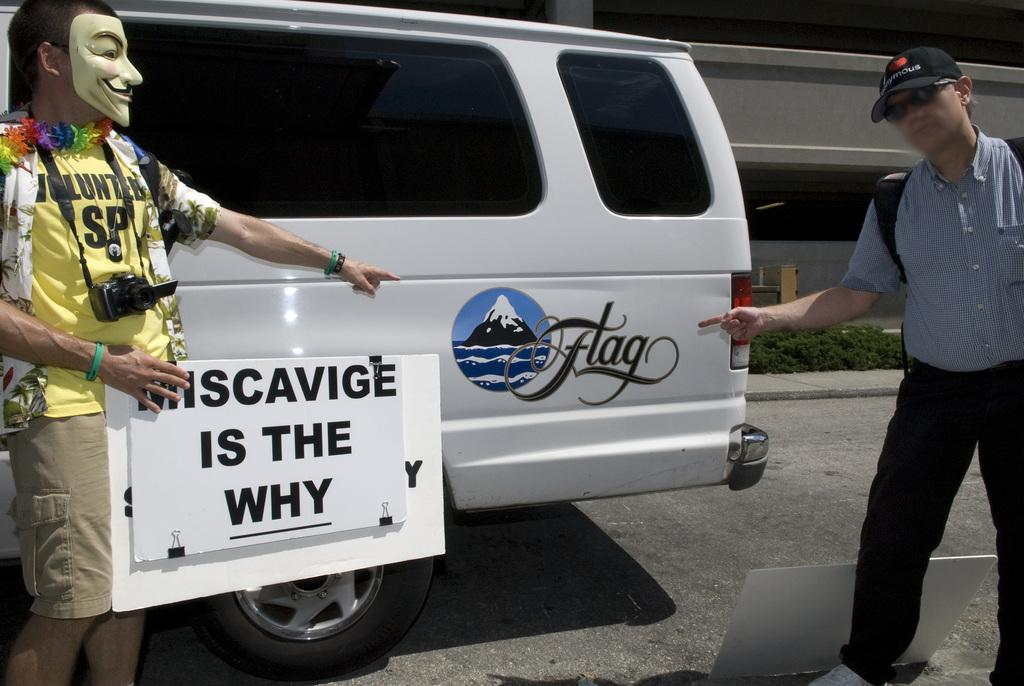<image>
Describe the image concisely. A person in a mask points at the word flag on a white van. 